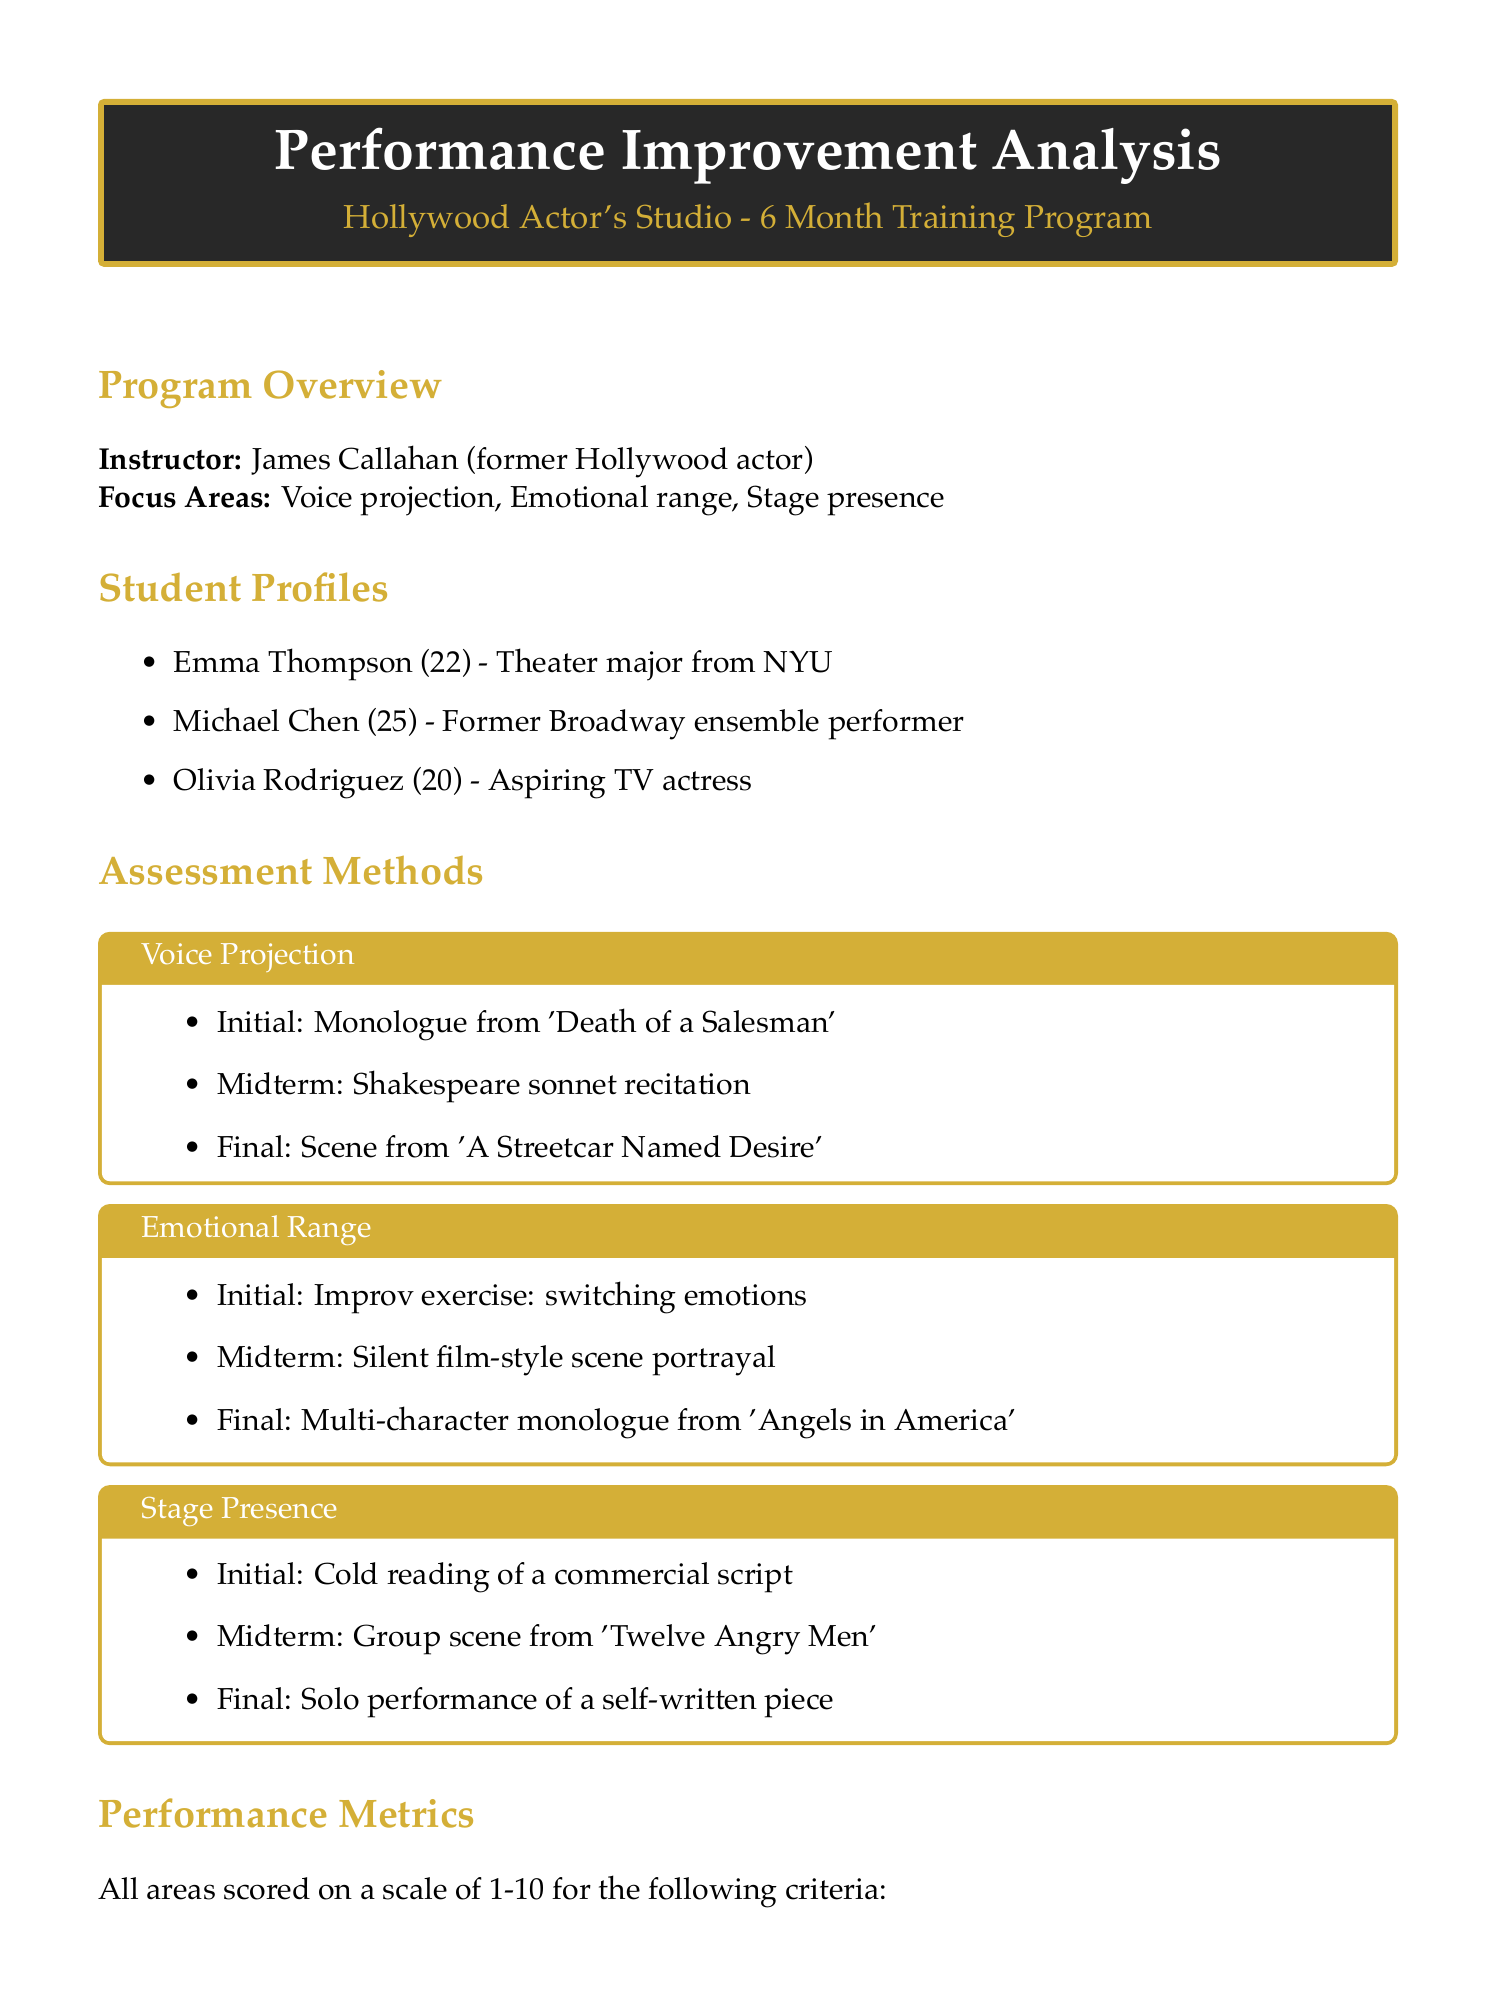What is the name of the instructor? The instructor's name is listed under the Program Overview section, which is James Callahan.
Answer: James Callahan How long is the training program? The duration of the training program is specified in the header of the training details, which is 6 months.
Answer: 6 months What is the most improved area? The most improved area of performance is stated in the Performance Results section, which is Emotional Range.
Answer: Emotional Range Who is the top performer? The top performer is mentioned in the Performance Results section, which identifies Olivia Rodriguez.
Answer: Olivia Rodriguez What was Olivia Rodriguez's overall improvement percentage? Olivia's overall improvement percentage is clearly stated in the Performance Results section, which is 47%.
Answer: 47% What are the focus areas of the training program? The focus areas are listed directly under the Program Overview, which includes Voice projection, Emotional range, and Stage presence.
Answer: Voice projection, Emotional range, Stage presence What notable achievement did Olivia Rodriguez have? Her notable achievements include landing a recurring role on a specific TV show, as mentioned in the Performance Results section.
Answer: Landed a recurring role on 'Law & Order: SVU' What are the guest lecturer topics? The document includes a list of guest lecturers and their topics, which covers aspects like accents, character building, and performance anxiety.
Answer: Mastering accents and dialects, Building a character from the inside out, Overcoming stage fright and performance anxiety What is the average improvement percentage for emotional range? The average improvement for emotional range is specified in the Performance Results section, indicating a percentage value.
Answer: 42% 